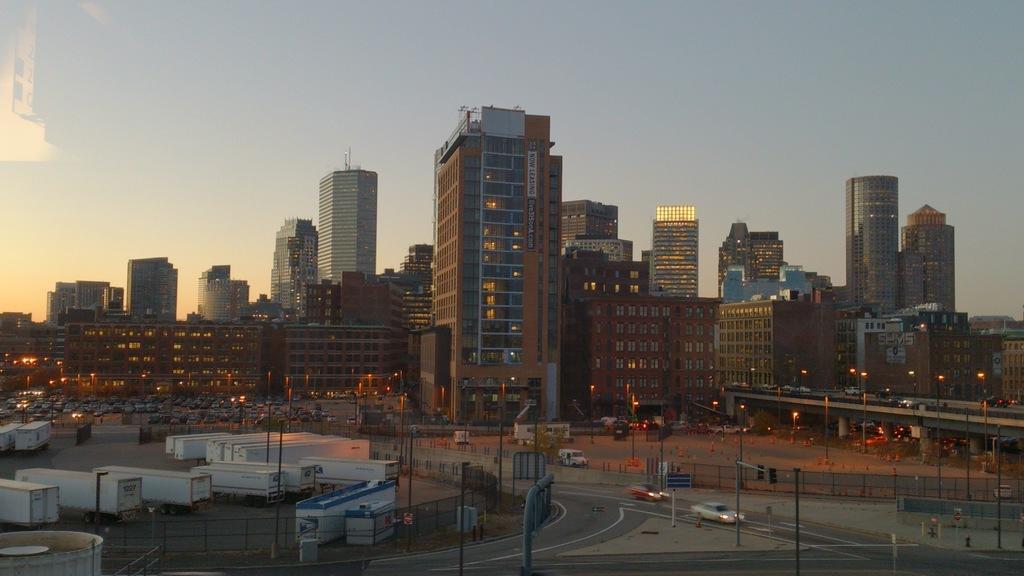Describe this image in one or two sentences. In the image there are many vehicles and around the vehicles there are poles and fencing, on the right side there is a bridge, behind the bridge there are plenty of buildings. 